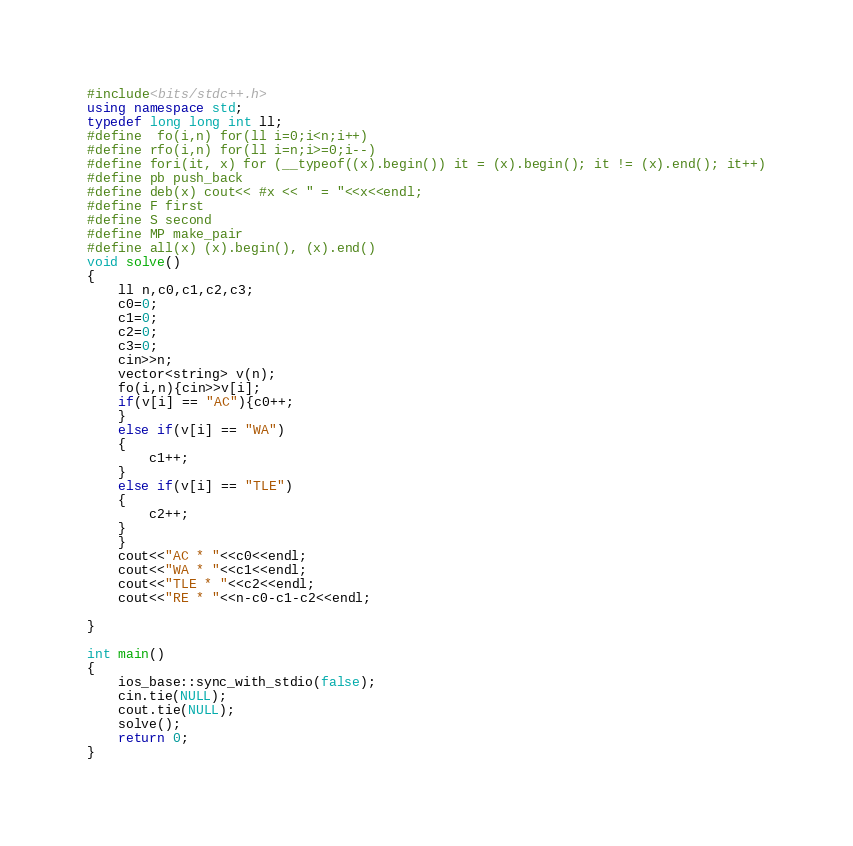<code> <loc_0><loc_0><loc_500><loc_500><_C++_>#include<bits/stdc++.h>
using namespace std;
typedef long long int ll;
#define  fo(i,n) for(ll i=0;i<n;i++)
#define rfo(i,n) for(ll i=n;i>=0;i--)
#define fori(it, x) for (__typeof((x).begin()) it = (x).begin(); it != (x).end(); it++)
#define pb push_back
#define deb(x) cout<< #x << " = "<<x<<endl;
#define F first
#define S second
#define MP make_pair
#define all(x) (x).begin(), (x).end()
void solve()
{
	ll n,c0,c1,c2,c3;
	c0=0;
	c1=0;
	c2=0;
	c3=0;
	cin>>n;
	vector<string> v(n);
	fo(i,n){cin>>v[i];
	if(v[i] == "AC"){c0++;
	}
	else if(v[i] == "WA")
	{
		c1++;
	}
	else if(v[i] == "TLE")
	{
		c2++;
	}
	}
	cout<<"AC * "<<c0<<endl;
	cout<<"WA * "<<c1<<endl;
	cout<<"TLE * "<<c2<<endl;
	cout<<"RE * "<<n-c0-c1-c2<<endl;
	
}

int main()
{
    ios_base::sync_with_stdio(false);
    cin.tie(NULL);
    cout.tie(NULL);
	solve();
    return 0;
}</code> 